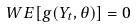<formula> <loc_0><loc_0><loc_500><loc_500>W E [ g ( Y _ { t } , \theta ) ] = 0</formula> 